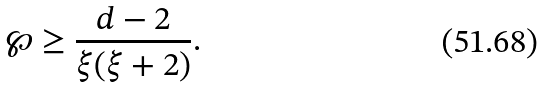Convert formula to latex. <formula><loc_0><loc_0><loc_500><loc_500>\wp \geq \frac { d - 2 } { \xi ( \xi + 2 ) } .</formula> 